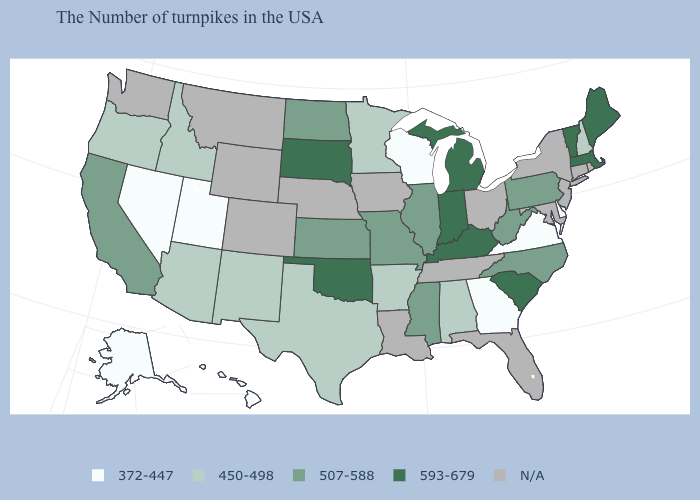What is the value of Kansas?
Quick response, please. 507-588. Name the states that have a value in the range 450-498?
Be succinct. New Hampshire, Alabama, Arkansas, Minnesota, Texas, New Mexico, Arizona, Idaho, Oregon. What is the highest value in the USA?
Write a very short answer. 593-679. Name the states that have a value in the range 372-447?
Be succinct. Delaware, Virginia, Georgia, Wisconsin, Utah, Nevada, Alaska, Hawaii. How many symbols are there in the legend?
Answer briefly. 5. What is the value of Idaho?
Quick response, please. 450-498. Among the states that border Nebraska , which have the highest value?
Be succinct. South Dakota. Name the states that have a value in the range 593-679?
Answer briefly. Maine, Massachusetts, Vermont, South Carolina, Michigan, Kentucky, Indiana, Oklahoma, South Dakota. How many symbols are there in the legend?
Quick response, please. 5. What is the highest value in states that border Utah?
Give a very brief answer. 450-498. What is the value of Nevada?
Be succinct. 372-447. What is the lowest value in the USA?
Be succinct. 372-447. Which states have the lowest value in the USA?
Be succinct. Delaware, Virginia, Georgia, Wisconsin, Utah, Nevada, Alaska, Hawaii. Name the states that have a value in the range 593-679?
Keep it brief. Maine, Massachusetts, Vermont, South Carolina, Michigan, Kentucky, Indiana, Oklahoma, South Dakota. Name the states that have a value in the range 507-588?
Concise answer only. Pennsylvania, North Carolina, West Virginia, Illinois, Mississippi, Missouri, Kansas, North Dakota, California. 